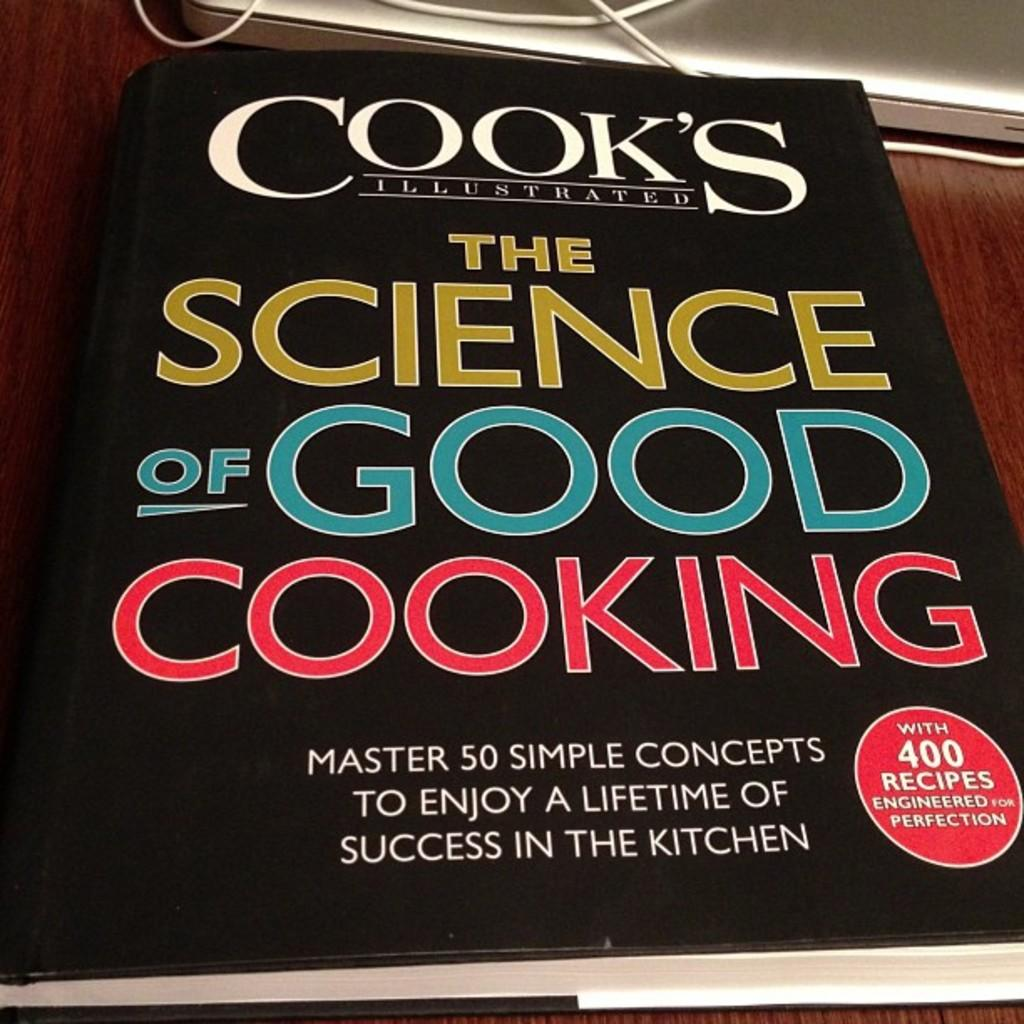<image>
Relay a brief, clear account of the picture shown. The Science of Good Cooking that includes 400 recipes. 